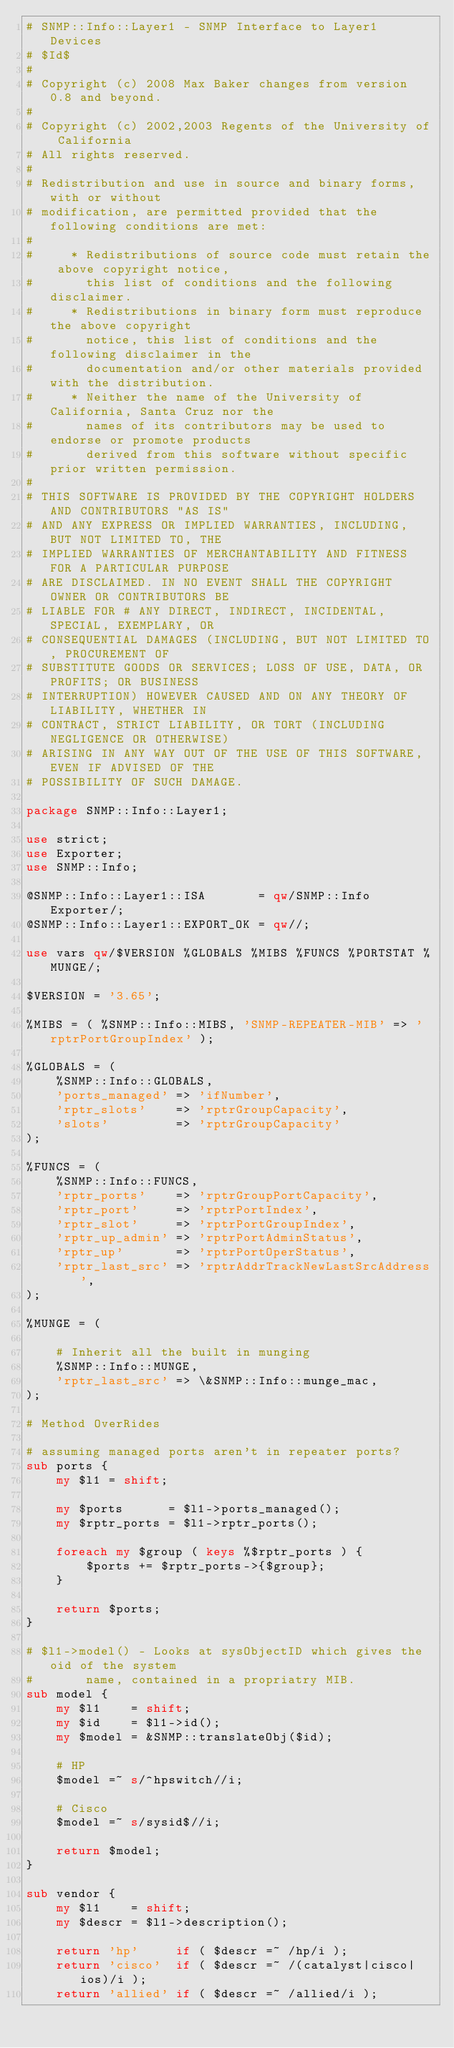Convert code to text. <code><loc_0><loc_0><loc_500><loc_500><_Perl_># SNMP::Info::Layer1 - SNMP Interface to Layer1 Devices
# $Id$
#
# Copyright (c) 2008 Max Baker changes from version 0.8 and beyond.
#
# Copyright (c) 2002,2003 Regents of the University of California
# All rights reserved.
#
# Redistribution and use in source and binary forms, with or without
# modification, are permitted provided that the following conditions are met:
#
#     * Redistributions of source code must retain the above copyright notice,
#       this list of conditions and the following disclaimer.
#     * Redistributions in binary form must reproduce the above copyright
#       notice, this list of conditions and the following disclaimer in the
#       documentation and/or other materials provided with the distribution.
#     * Neither the name of the University of California, Santa Cruz nor the
#       names of its contributors may be used to endorse or promote products
#       derived from this software without specific prior written permission.
#
# THIS SOFTWARE IS PROVIDED BY THE COPYRIGHT HOLDERS AND CONTRIBUTORS "AS IS"
# AND ANY EXPRESS OR IMPLIED WARRANTIES, INCLUDING, BUT NOT LIMITED TO, THE
# IMPLIED WARRANTIES OF MERCHANTABILITY AND FITNESS FOR A PARTICULAR PURPOSE
# ARE DISCLAIMED. IN NO EVENT SHALL THE COPYRIGHT OWNER OR CONTRIBUTORS BE
# LIABLE FOR # ANY DIRECT, INDIRECT, INCIDENTAL, SPECIAL, EXEMPLARY, OR
# CONSEQUENTIAL DAMAGES (INCLUDING, BUT NOT LIMITED TO, PROCUREMENT OF
# SUBSTITUTE GOODS OR SERVICES; LOSS OF USE, DATA, OR PROFITS; OR BUSINESS
# INTERRUPTION) HOWEVER CAUSED AND ON ANY THEORY OF LIABILITY, WHETHER IN
# CONTRACT, STRICT LIABILITY, OR TORT (INCLUDING NEGLIGENCE OR OTHERWISE)
# ARISING IN ANY WAY OUT OF THE USE OF THIS SOFTWARE, EVEN IF ADVISED OF THE
# POSSIBILITY OF SUCH DAMAGE.

package SNMP::Info::Layer1;

use strict;
use Exporter;
use SNMP::Info;

@SNMP::Info::Layer1::ISA       = qw/SNMP::Info Exporter/;
@SNMP::Info::Layer1::EXPORT_OK = qw//;

use vars qw/$VERSION %GLOBALS %MIBS %FUNCS %PORTSTAT %MUNGE/;

$VERSION = '3.65';

%MIBS = ( %SNMP::Info::MIBS, 'SNMP-REPEATER-MIB' => 'rptrPortGroupIndex' );

%GLOBALS = (
    %SNMP::Info::GLOBALS,
    'ports_managed' => 'ifNumber',
    'rptr_slots'    => 'rptrGroupCapacity',
    'slots'         => 'rptrGroupCapacity'
);

%FUNCS = (
    %SNMP::Info::FUNCS,
    'rptr_ports'    => 'rptrGroupPortCapacity',
    'rptr_port'     => 'rptrPortIndex',
    'rptr_slot'     => 'rptrPortGroupIndex',
    'rptr_up_admin' => 'rptrPortAdminStatus',
    'rptr_up'       => 'rptrPortOperStatus',
    'rptr_last_src' => 'rptrAddrTrackNewLastSrcAddress',
);

%MUNGE = (

    # Inherit all the built in munging
    %SNMP::Info::MUNGE,
    'rptr_last_src' => \&SNMP::Info::munge_mac,
);

# Method OverRides

# assuming managed ports aren't in repeater ports?
sub ports {
    my $l1 = shift;

    my $ports      = $l1->ports_managed();
    my $rptr_ports = $l1->rptr_ports();

    foreach my $group ( keys %$rptr_ports ) {
        $ports += $rptr_ports->{$group};
    }

    return $ports;
}

# $l1->model() - Looks at sysObjectID which gives the oid of the system
#       name, contained in a propriatry MIB.
sub model {
    my $l1    = shift;
    my $id    = $l1->id();
    my $model = &SNMP::translateObj($id);

    # HP
    $model =~ s/^hpswitch//i;

    # Cisco
    $model =~ s/sysid$//i;

    return $model;
}

sub vendor {
    my $l1    = shift;
    my $descr = $l1->description();

    return 'hp'     if ( $descr =~ /hp/i );
    return 'cisco'  if ( $descr =~ /(catalyst|cisco|ios)/i );
    return 'allied' if ( $descr =~ /allied/i );</code> 